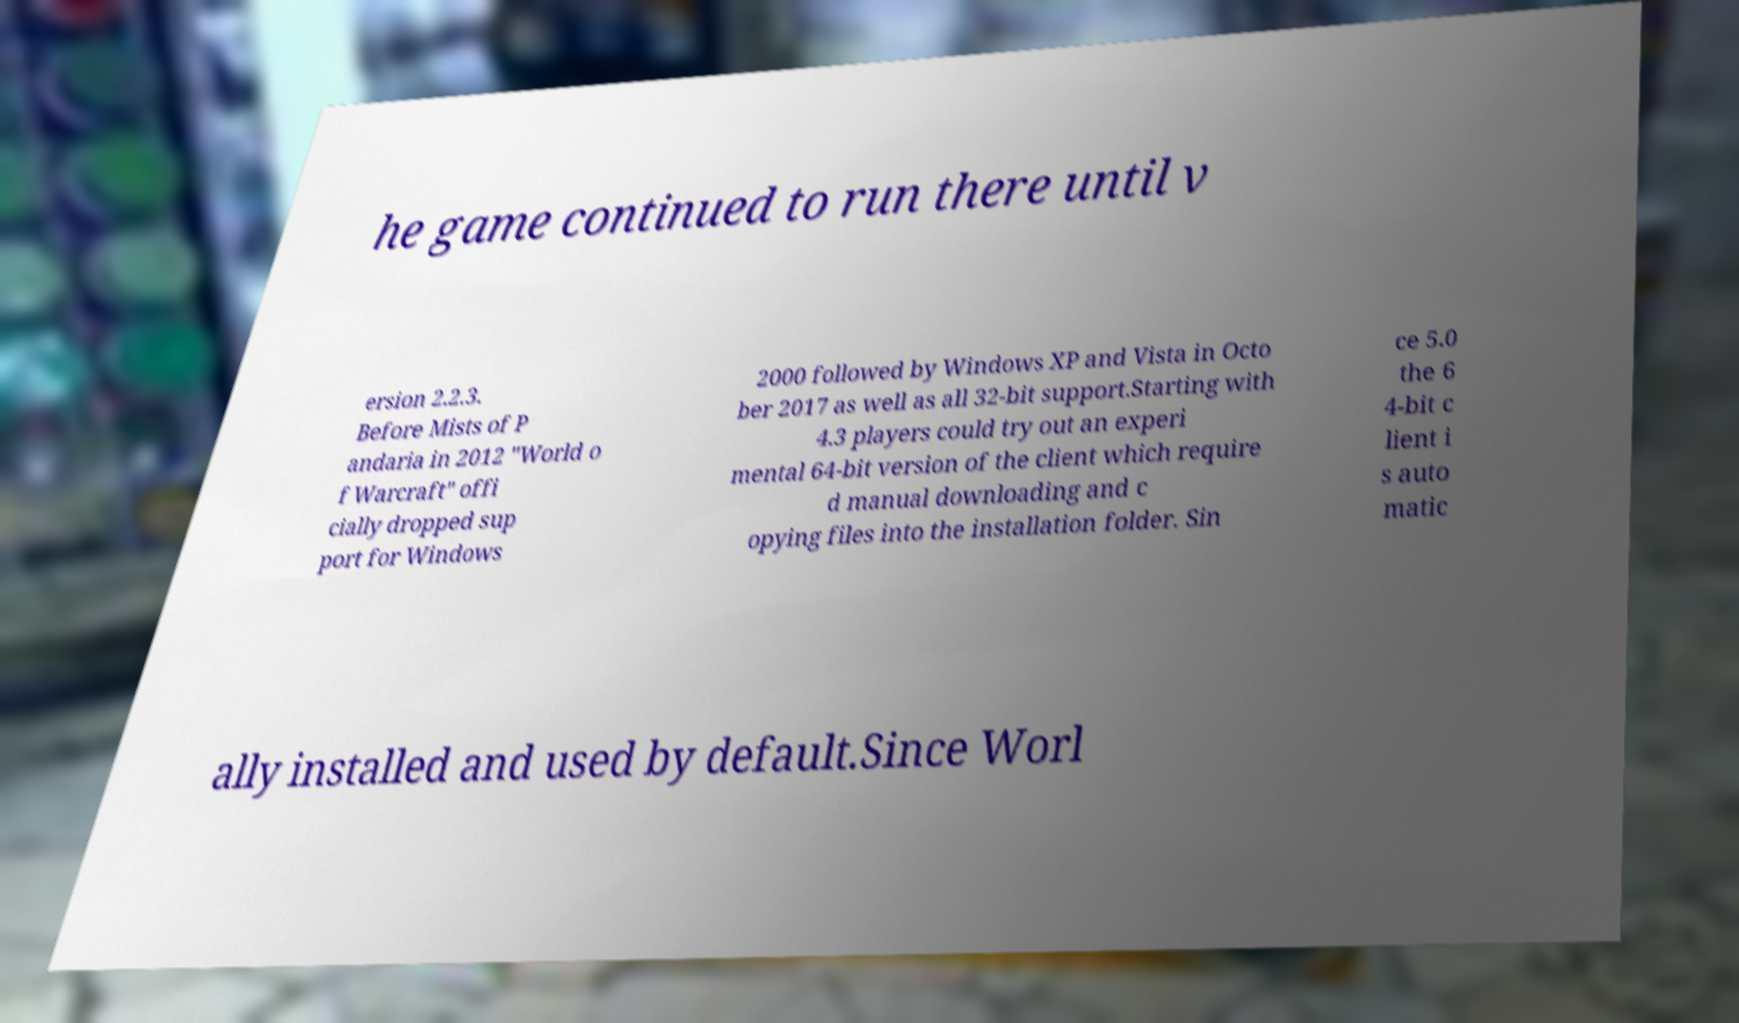Could you assist in decoding the text presented in this image and type it out clearly? he game continued to run there until v ersion 2.2.3. Before Mists of P andaria in 2012 "World o f Warcraft" offi cially dropped sup port for Windows 2000 followed by Windows XP and Vista in Octo ber 2017 as well as all 32-bit support.Starting with 4.3 players could try out an experi mental 64-bit version of the client which require d manual downloading and c opying files into the installation folder. Sin ce 5.0 the 6 4-bit c lient i s auto matic ally installed and used by default.Since Worl 